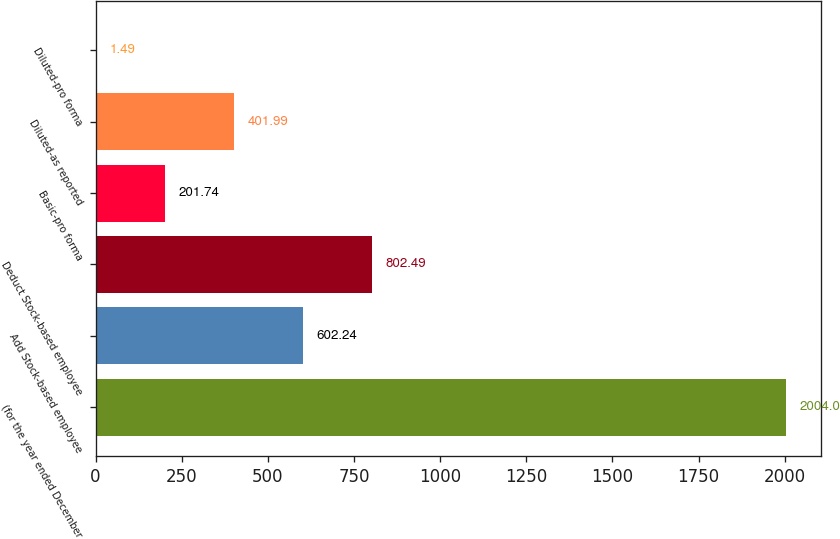Convert chart. <chart><loc_0><loc_0><loc_500><loc_500><bar_chart><fcel>(for the year ended December<fcel>Add Stock-based employee<fcel>Deduct Stock-based employee<fcel>Basic-pro forma<fcel>Diluted-as reported<fcel>Diluted-pro forma<nl><fcel>2004<fcel>602.24<fcel>802.49<fcel>201.74<fcel>401.99<fcel>1.49<nl></chart> 